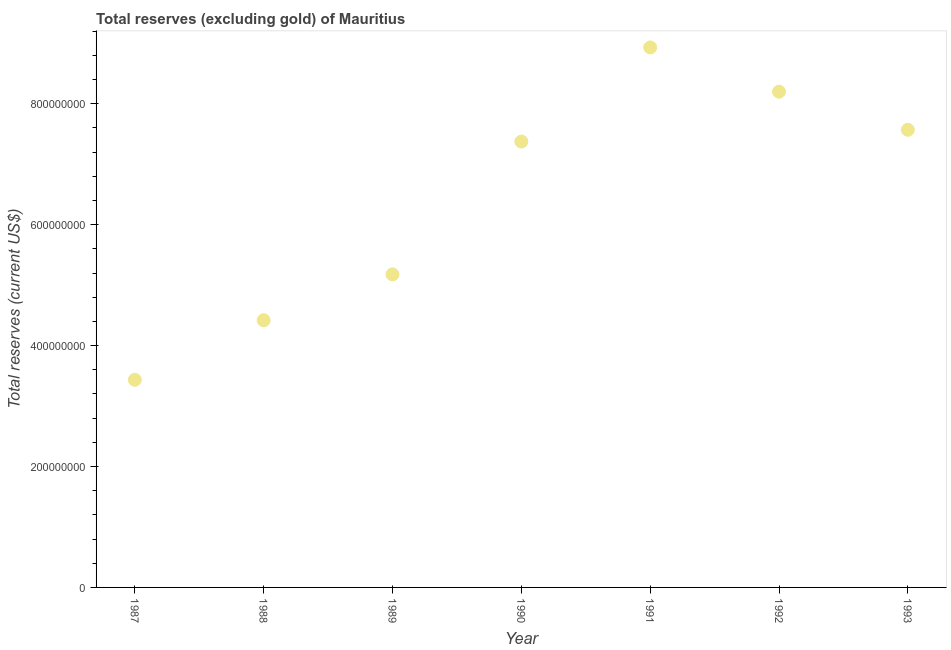What is the total reserves (excluding gold) in 1990?
Your answer should be very brief. 7.38e+08. Across all years, what is the maximum total reserves (excluding gold)?
Ensure brevity in your answer.  8.93e+08. Across all years, what is the minimum total reserves (excluding gold)?
Give a very brief answer. 3.43e+08. In which year was the total reserves (excluding gold) minimum?
Give a very brief answer. 1987. What is the sum of the total reserves (excluding gold)?
Give a very brief answer. 4.51e+09. What is the difference between the total reserves (excluding gold) in 1987 and 1991?
Your answer should be very brief. -5.50e+08. What is the average total reserves (excluding gold) per year?
Provide a succinct answer. 6.44e+08. What is the median total reserves (excluding gold)?
Your answer should be compact. 7.38e+08. In how many years, is the total reserves (excluding gold) greater than 480000000 US$?
Your answer should be compact. 5. Do a majority of the years between 1988 and 1989 (inclusive) have total reserves (excluding gold) greater than 360000000 US$?
Provide a short and direct response. Yes. What is the ratio of the total reserves (excluding gold) in 1990 to that in 1992?
Ensure brevity in your answer.  0.9. What is the difference between the highest and the second highest total reserves (excluding gold)?
Give a very brief answer. 7.32e+07. Is the sum of the total reserves (excluding gold) in 1987 and 1989 greater than the maximum total reserves (excluding gold) across all years?
Give a very brief answer. No. What is the difference between the highest and the lowest total reserves (excluding gold)?
Provide a succinct answer. 5.50e+08. In how many years, is the total reserves (excluding gold) greater than the average total reserves (excluding gold) taken over all years?
Your response must be concise. 4. Does the total reserves (excluding gold) monotonically increase over the years?
Keep it short and to the point. No. What is the difference between two consecutive major ticks on the Y-axis?
Offer a terse response. 2.00e+08. What is the title of the graph?
Your response must be concise. Total reserves (excluding gold) of Mauritius. What is the label or title of the Y-axis?
Keep it short and to the point. Total reserves (current US$). What is the Total reserves (current US$) in 1987?
Your answer should be very brief. 3.43e+08. What is the Total reserves (current US$) in 1988?
Ensure brevity in your answer.  4.42e+08. What is the Total reserves (current US$) in 1989?
Keep it short and to the point. 5.18e+08. What is the Total reserves (current US$) in 1990?
Your answer should be compact. 7.38e+08. What is the Total reserves (current US$) in 1991?
Your answer should be compact. 8.93e+08. What is the Total reserves (current US$) in 1992?
Ensure brevity in your answer.  8.20e+08. What is the Total reserves (current US$) in 1993?
Your answer should be very brief. 7.57e+08. What is the difference between the Total reserves (current US$) in 1987 and 1988?
Your answer should be very brief. -9.85e+07. What is the difference between the Total reserves (current US$) in 1987 and 1989?
Ensure brevity in your answer.  -1.74e+08. What is the difference between the Total reserves (current US$) in 1987 and 1990?
Offer a terse response. -3.94e+08. What is the difference between the Total reserves (current US$) in 1987 and 1991?
Your answer should be compact. -5.50e+08. What is the difference between the Total reserves (current US$) in 1987 and 1992?
Provide a short and direct response. -4.77e+08. What is the difference between the Total reserves (current US$) in 1987 and 1993?
Provide a succinct answer. -4.14e+08. What is the difference between the Total reserves (current US$) in 1988 and 1989?
Provide a succinct answer. -7.59e+07. What is the difference between the Total reserves (current US$) in 1988 and 1990?
Offer a very short reply. -2.96e+08. What is the difference between the Total reserves (current US$) in 1988 and 1991?
Offer a very short reply. -4.51e+08. What is the difference between the Total reserves (current US$) in 1988 and 1992?
Your response must be concise. -3.78e+08. What is the difference between the Total reserves (current US$) in 1988 and 1993?
Provide a short and direct response. -3.15e+08. What is the difference between the Total reserves (current US$) in 1989 and 1990?
Your answer should be very brief. -2.20e+08. What is the difference between the Total reserves (current US$) in 1989 and 1991?
Provide a succinct answer. -3.75e+08. What is the difference between the Total reserves (current US$) in 1989 and 1992?
Your answer should be compact. -3.02e+08. What is the difference between the Total reserves (current US$) in 1989 and 1993?
Your answer should be compact. -2.39e+08. What is the difference between the Total reserves (current US$) in 1990 and 1991?
Make the answer very short. -1.56e+08. What is the difference between the Total reserves (current US$) in 1990 and 1992?
Provide a short and direct response. -8.25e+07. What is the difference between the Total reserves (current US$) in 1990 and 1993?
Your response must be concise. -1.94e+07. What is the difference between the Total reserves (current US$) in 1991 and 1992?
Offer a very short reply. 7.32e+07. What is the difference between the Total reserves (current US$) in 1991 and 1993?
Provide a short and direct response. 1.36e+08. What is the difference between the Total reserves (current US$) in 1992 and 1993?
Provide a succinct answer. 6.30e+07. What is the ratio of the Total reserves (current US$) in 1987 to that in 1988?
Provide a succinct answer. 0.78. What is the ratio of the Total reserves (current US$) in 1987 to that in 1989?
Keep it short and to the point. 0.66. What is the ratio of the Total reserves (current US$) in 1987 to that in 1990?
Offer a terse response. 0.47. What is the ratio of the Total reserves (current US$) in 1987 to that in 1991?
Offer a very short reply. 0.39. What is the ratio of the Total reserves (current US$) in 1987 to that in 1992?
Offer a very short reply. 0.42. What is the ratio of the Total reserves (current US$) in 1987 to that in 1993?
Provide a short and direct response. 0.45. What is the ratio of the Total reserves (current US$) in 1988 to that in 1989?
Give a very brief answer. 0.85. What is the ratio of the Total reserves (current US$) in 1988 to that in 1990?
Give a very brief answer. 0.6. What is the ratio of the Total reserves (current US$) in 1988 to that in 1991?
Your response must be concise. 0.49. What is the ratio of the Total reserves (current US$) in 1988 to that in 1992?
Give a very brief answer. 0.54. What is the ratio of the Total reserves (current US$) in 1988 to that in 1993?
Provide a succinct answer. 0.58. What is the ratio of the Total reserves (current US$) in 1989 to that in 1990?
Your response must be concise. 0.7. What is the ratio of the Total reserves (current US$) in 1989 to that in 1991?
Provide a short and direct response. 0.58. What is the ratio of the Total reserves (current US$) in 1989 to that in 1992?
Your answer should be very brief. 0.63. What is the ratio of the Total reserves (current US$) in 1989 to that in 1993?
Keep it short and to the point. 0.68. What is the ratio of the Total reserves (current US$) in 1990 to that in 1991?
Offer a very short reply. 0.83. What is the ratio of the Total reserves (current US$) in 1990 to that in 1992?
Ensure brevity in your answer.  0.9. What is the ratio of the Total reserves (current US$) in 1990 to that in 1993?
Give a very brief answer. 0.97. What is the ratio of the Total reserves (current US$) in 1991 to that in 1992?
Make the answer very short. 1.09. What is the ratio of the Total reserves (current US$) in 1991 to that in 1993?
Ensure brevity in your answer.  1.18. What is the ratio of the Total reserves (current US$) in 1992 to that in 1993?
Offer a very short reply. 1.08. 